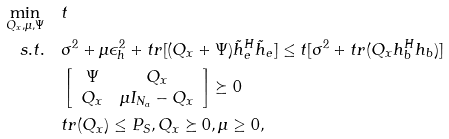Convert formula to latex. <formula><loc_0><loc_0><loc_500><loc_500>\min _ { Q _ { x } , \mu , \Psi } & \quad t \\ { s . t . } & \quad \sigma ^ { 2 } + \mu \epsilon _ { h } ^ { 2 } + { t r } [ ( Q _ { x } + \Psi ) \tilde { h } _ { e } ^ { H } \tilde { h } _ { e } ] \leq t [ \sigma ^ { 2 } + { t r } ( Q _ { x } h _ { b } ^ { H } h _ { b } ) ] \\ & \quad \left [ \begin{array} { c c } \Psi & Q _ { x } \\ Q _ { x } & \mu I _ { N _ { a } } - Q _ { x } \end{array} \right ] \succeq 0 \\ & \quad t r ( Q _ { x } ) \leq P _ { S } , Q _ { x } \succeq 0 , \mu \geq 0 ,</formula> 